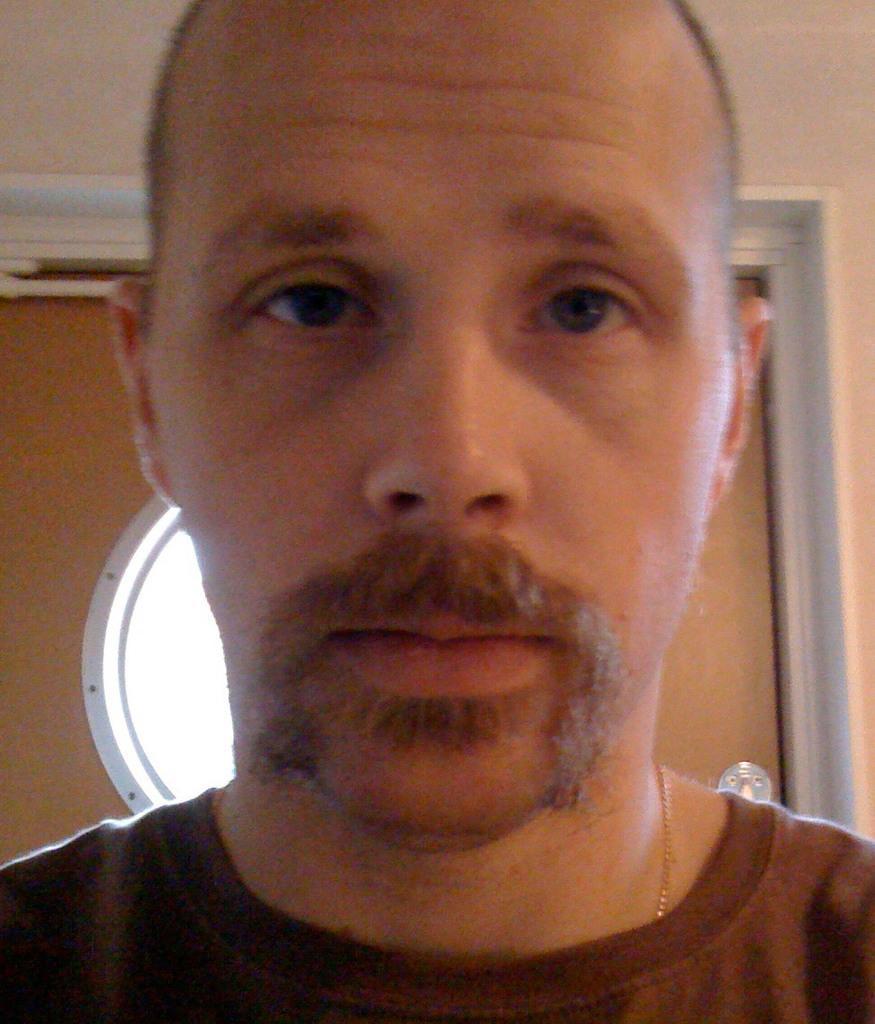In one or two sentences, can you explain what this image depicts? In the center of the image we can see a man. In the background there is a wall and a door. 